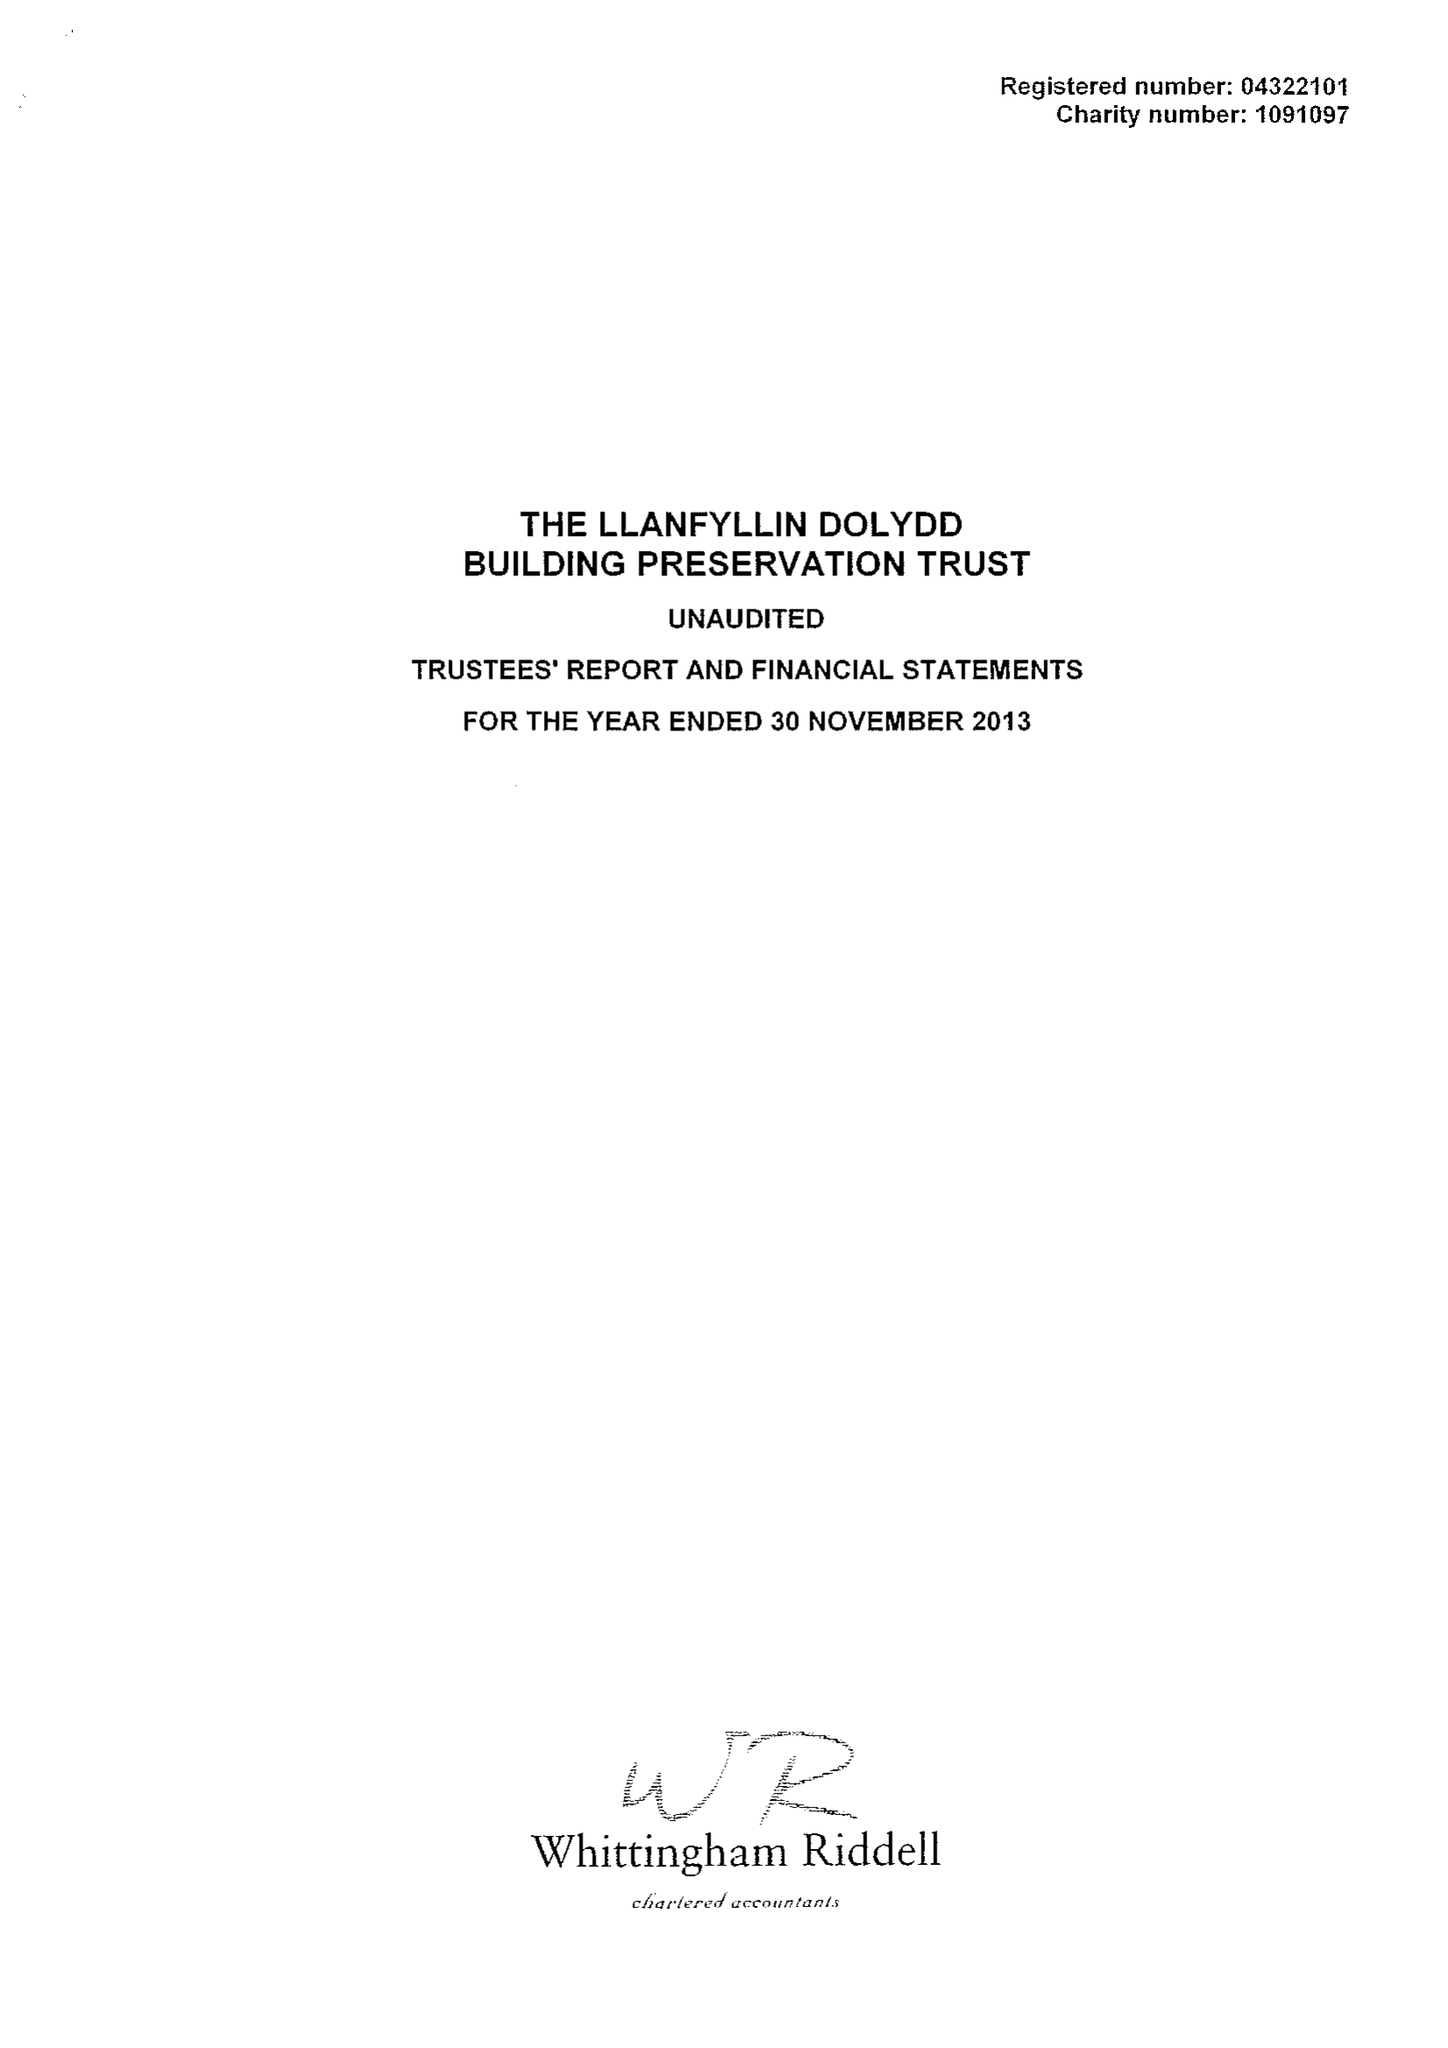What is the value for the address__postcode?
Answer the question using a single word or phrase. SY10 0HA 